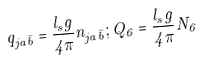<formula> <loc_0><loc_0><loc_500><loc_500>q _ { j a \bar { b } } = { \frac { l _ { s } g } { 4 \pi } } n _ { j a \bar { b } } ; Q _ { 6 } = { \frac { l _ { s } g } { 4 \pi } } N _ { 6 }</formula> 